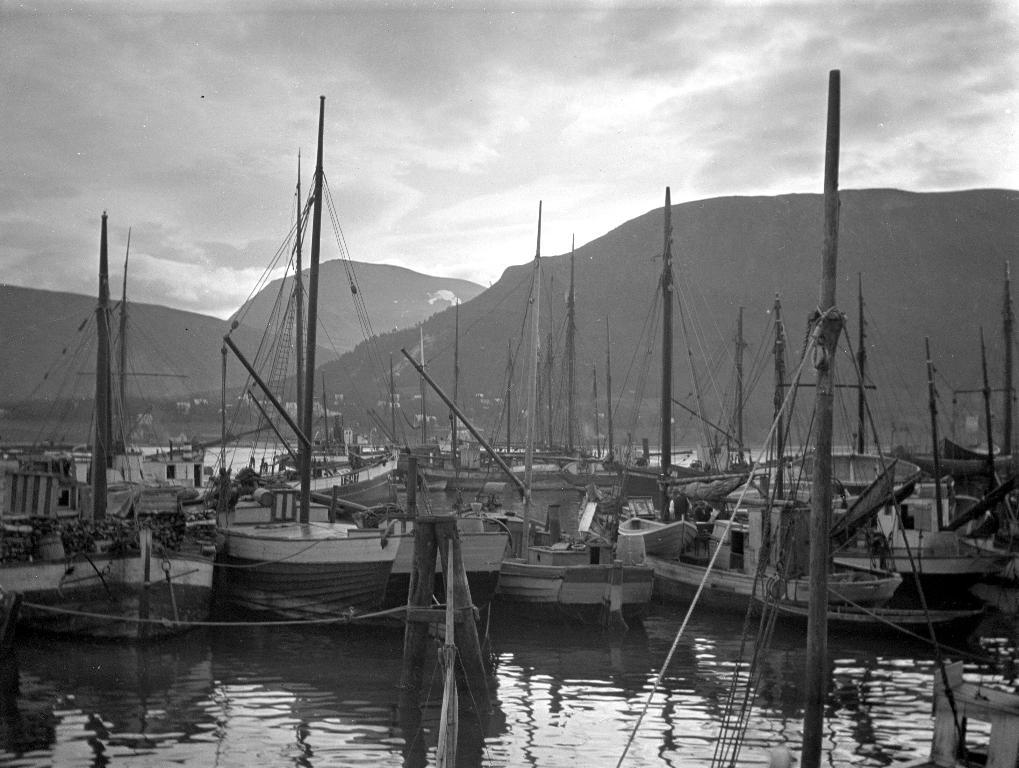What is the color scheme of the image? The image is black and white. What can be seen on the water in the image? There are ships on the water in the image. What is visible in the background of the image? There are mountains in the background of the image. What is visible in the sky in the image? Clouds are visible in the sky in the image. What is the father's voice like in the image? There is no reference to a father or any voice in the image, as it features ships on the water with mountains and clouds in the background. 